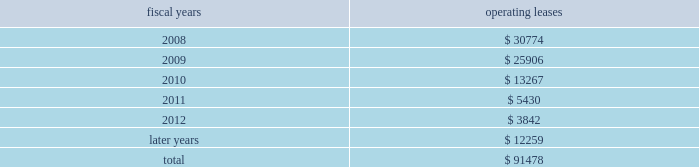Stock option gains previously deferred by those participants pursuant to the terms of the deferred compensation plan and earnings on those deferred amounts .
As a result of certain provisions of the american jobs creation act , participants had the opportunity until december 31 , 2005 to elect to withdraw amounts previously deferred .
11 .
Lease commitments the company leases certain of its facilities , equipment and software under various operating leases that expire at various dates through 2022 .
The lease agreements frequently include renewal and escalation clauses and require the company to pay taxes , insurance and maintenance costs .
Total rental expense under operating leases was approximately $ 43 million in fiscal 2007 , $ 45 million in fiscal 2006 and $ 44 million in fiscal 2005 .
The following is a schedule of future minimum rental payments required under long-term operating leases at november 3 , 2007 : fiscal years operating leases .
12 .
Commitments and contingencies tentative settlement of the sec 2019s previously announced stock option investigation in the company 2019s 2004 form 10-k filing , the company disclosed that the securities and exchange com- mission ( sec ) had initiated an inquiry into its stock option granting practices , focusing on options that were granted shortly before the issuance of favorable financial results .
On november 15 , 2005 , the company announced that it had reached a tentative settlement with the sec .
At all times since receiving notice of this inquiry , the company has cooperated with the sec .
In november 2005 , the company and its president and ceo , mr .
Jerald g .
Fishman , made an offer of settlement to the staff of the sec .
The settlement has been submitted to the commission for approval .
There can be no assurance a final settlement will be so approved .
The sec 2019s inquiry focused on two separate issues .
The first issue concerned the company 2019s disclosure regarding grants of options to employees and directors prior to the release of favorable financial results .
Specifically , the issue related to options granted to employees ( including officers ) of the company on november 30 , 1999 and to employees ( including officers ) and directors of the company on november 10 , 2000 .
The second issue concerned the grant dates for options granted to employees ( including officers ) in 1998 and 1999 , and the grant date for options granted to employees ( including officers ) and directors in 2001 .
Specifically , the settlement would conclude that the appropriate grant date for the september 4 , 1998 options should have been september 8th ( which is one trading day later than the date that was used to price the options ) ; the appropriate grant date for the november 30 , 1999 options should have been november 29th ( which is one trading day earlier than the date that was used ) ; and the appropriate grant date for the july 18 , 2001 options should have been july 26th ( which is five trading days after the original date ) .
Analog devices , inc .
Notes to consolidated financial statements 2014 ( continued ) .
What is the expected growth rate in rental expense under operating leases in 2008? 
Computations: (((30774 / 1000) - 43) / 43)
Answer: -0.28433. 